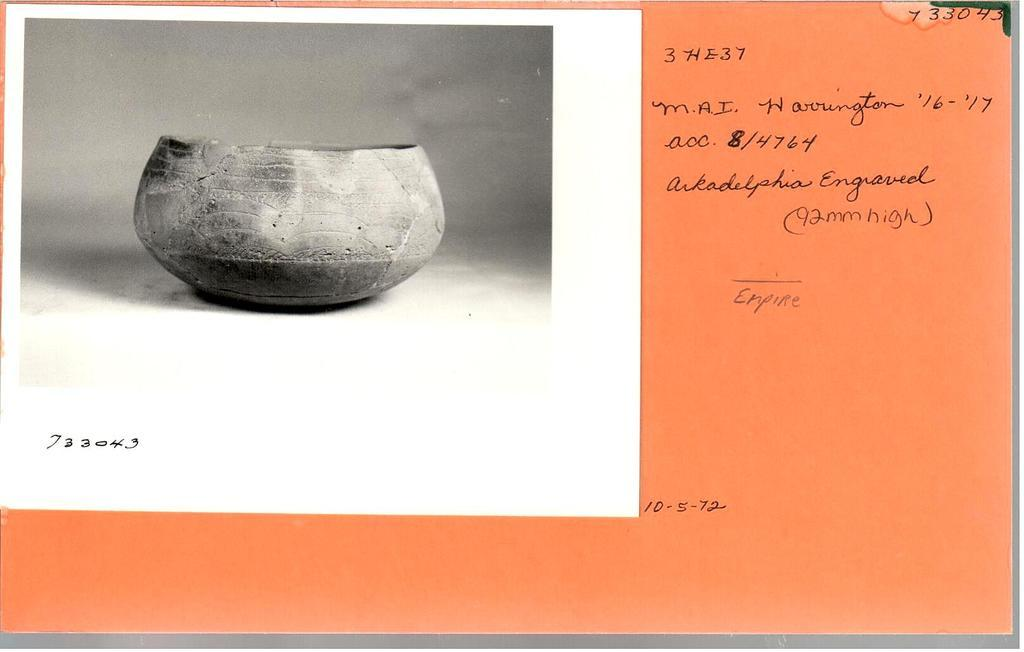What is the main object in the image? There is a postcard in the image. What is depicted on the left side of the postcard? The postcard has a black and white photo of a vessel on the left side. What can be seen on the right side of the postcard? There is handwritten text on the right side of the postcard. What type of border is around the postcard in the image? There is no information about a border on the postcard in the provided facts. Can you tell me what the writer of the handwritten text is wearing? The provided facts do not mention the writer of the handwritten text or their clothing. 